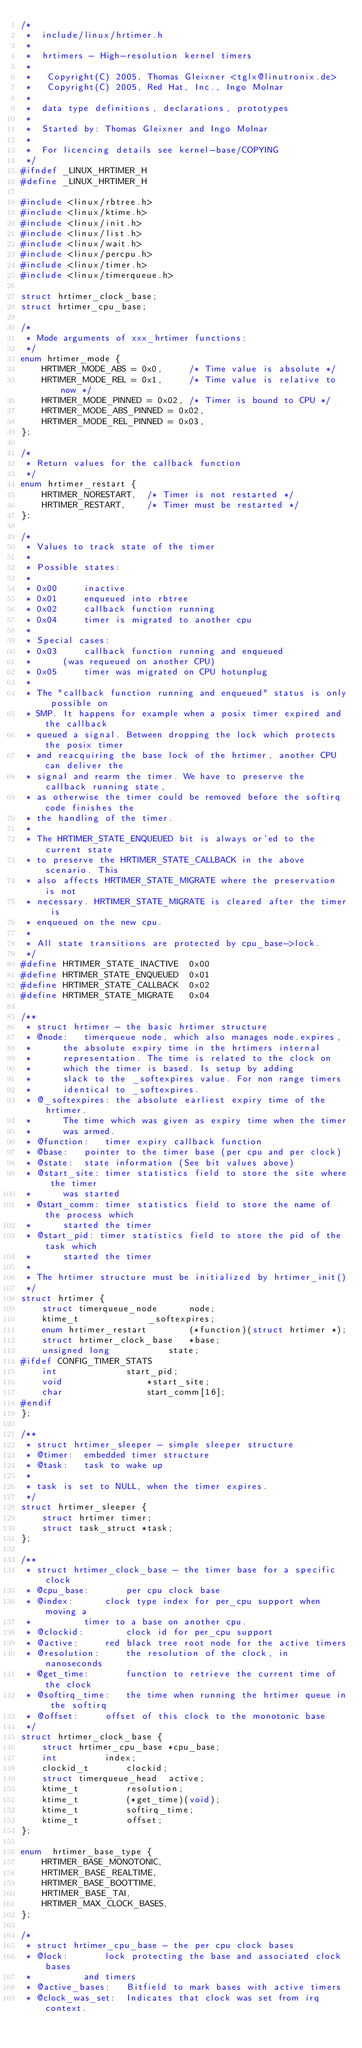Convert code to text. <code><loc_0><loc_0><loc_500><loc_500><_C_>/*
 *  include/linux/hrtimer.h
 *
 *  hrtimers - High-resolution kernel timers
 *
 *   Copyright(C) 2005, Thomas Gleixner <tglx@linutronix.de>
 *   Copyright(C) 2005, Red Hat, Inc., Ingo Molnar
 *
 *  data type definitions, declarations, prototypes
 *
 *  Started by: Thomas Gleixner and Ingo Molnar
 *
 *  For licencing details see kernel-base/COPYING
 */
#ifndef _LINUX_HRTIMER_H
#define _LINUX_HRTIMER_H

#include <linux/rbtree.h>
#include <linux/ktime.h>
#include <linux/init.h>
#include <linux/list.h>
#include <linux/wait.h>
#include <linux/percpu.h>
#include <linux/timer.h>
#include <linux/timerqueue.h>

struct hrtimer_clock_base;
struct hrtimer_cpu_base;

/*
 * Mode arguments of xxx_hrtimer functions:
 */
enum hrtimer_mode {
	HRTIMER_MODE_ABS = 0x0,		/* Time value is absolute */
	HRTIMER_MODE_REL = 0x1,		/* Time value is relative to now */
	HRTIMER_MODE_PINNED = 0x02,	/* Timer is bound to CPU */
	HRTIMER_MODE_ABS_PINNED = 0x02,
	HRTIMER_MODE_REL_PINNED = 0x03,
};

/*
 * Return values for the callback function
 */
enum hrtimer_restart {
	HRTIMER_NORESTART,	/* Timer is not restarted */
	HRTIMER_RESTART,	/* Timer must be restarted */
};

/*
 * Values to track state of the timer
 *
 * Possible states:
 *
 * 0x00		inactive
 * 0x01		enqueued into rbtree
 * 0x02		callback function running
 * 0x04		timer is migrated to another cpu
 *
 * Special cases:
 * 0x03		callback function running and enqueued
 *		(was requeued on another CPU)
 * 0x05		timer was migrated on CPU hotunplug
 *
 * The "callback function running and enqueued" status is only possible on
 * SMP. It happens for example when a posix timer expired and the callback
 * queued a signal. Between dropping the lock which protects the posix timer
 * and reacquiring the base lock of the hrtimer, another CPU can deliver the
 * signal and rearm the timer. We have to preserve the callback running state,
 * as otherwise the timer could be removed before the softirq code finishes the
 * the handling of the timer.
 *
 * The HRTIMER_STATE_ENQUEUED bit is always or'ed to the current state
 * to preserve the HRTIMER_STATE_CALLBACK in the above scenario. This
 * also affects HRTIMER_STATE_MIGRATE where the preservation is not
 * necessary. HRTIMER_STATE_MIGRATE is cleared after the timer is
 * enqueued on the new cpu.
 *
 * All state transitions are protected by cpu_base->lock.
 */
#define HRTIMER_STATE_INACTIVE	0x00
#define HRTIMER_STATE_ENQUEUED	0x01
#define HRTIMER_STATE_CALLBACK	0x02
#define HRTIMER_STATE_MIGRATE	0x04

/**
 * struct hrtimer - the basic hrtimer structure
 * @node:	timerqueue node, which also manages node.expires,
 *		the absolute expiry time in the hrtimers internal
 *		representation. The time is related to the clock on
 *		which the timer is based. Is setup by adding
 *		slack to the _softexpires value. For non range timers
 *		identical to _softexpires.
 * @_softexpires: the absolute earliest expiry time of the hrtimer.
 *		The time which was given as expiry time when the timer
 *		was armed.
 * @function:	timer expiry callback function
 * @base:	pointer to the timer base (per cpu and per clock)
 * @state:	state information (See bit values above)
 * @start_site:	timer statistics field to store the site where the timer
 *		was started
 * @start_comm: timer statistics field to store the name of the process which
 *		started the timer
 * @start_pid: timer statistics field to store the pid of the task which
 *		started the timer
 *
 * The hrtimer structure must be initialized by hrtimer_init()
 */
struct hrtimer {
	struct timerqueue_node		node;
	ktime_t				_softexpires;
	enum hrtimer_restart		(*function)(struct hrtimer *);
	struct hrtimer_clock_base	*base;
	unsigned long			state;
#ifdef CONFIG_TIMER_STATS
	int				start_pid;
	void				*start_site;
	char				start_comm[16];
#endif
};

/**
 * struct hrtimer_sleeper - simple sleeper structure
 * @timer:	embedded timer structure
 * @task:	task to wake up
 *
 * task is set to NULL, when the timer expires.
 */
struct hrtimer_sleeper {
	struct hrtimer timer;
	struct task_struct *task;
};

/**
 * struct hrtimer_clock_base - the timer base for a specific clock
 * @cpu_base:		per cpu clock base
 * @index:		clock type index for per_cpu support when moving a
 *			timer to a base on another cpu.
 * @clockid:		clock id for per_cpu support
 * @active:		red black tree root node for the active timers
 * @resolution:		the resolution of the clock, in nanoseconds
 * @get_time:		function to retrieve the current time of the clock
 * @softirq_time:	the time when running the hrtimer queue in the softirq
 * @offset:		offset of this clock to the monotonic base
 */
struct hrtimer_clock_base {
	struct hrtimer_cpu_base	*cpu_base;
	int			index;
	clockid_t		clockid;
	struct timerqueue_head	active;
	ktime_t			resolution;
	ktime_t			(*get_time)(void);
	ktime_t			softirq_time;
	ktime_t			offset;
};

enum  hrtimer_base_type {
	HRTIMER_BASE_MONOTONIC,
	HRTIMER_BASE_REALTIME,
	HRTIMER_BASE_BOOTTIME,
	HRTIMER_BASE_TAI,
	HRTIMER_MAX_CLOCK_BASES,
};

/*
 * struct hrtimer_cpu_base - the per cpu clock bases
 * @lock:		lock protecting the base and associated clock bases
 *			and timers
 * @active_bases:	Bitfield to mark bases with active timers
 * @clock_was_set:	Indicates that clock was set from irq context.</code> 